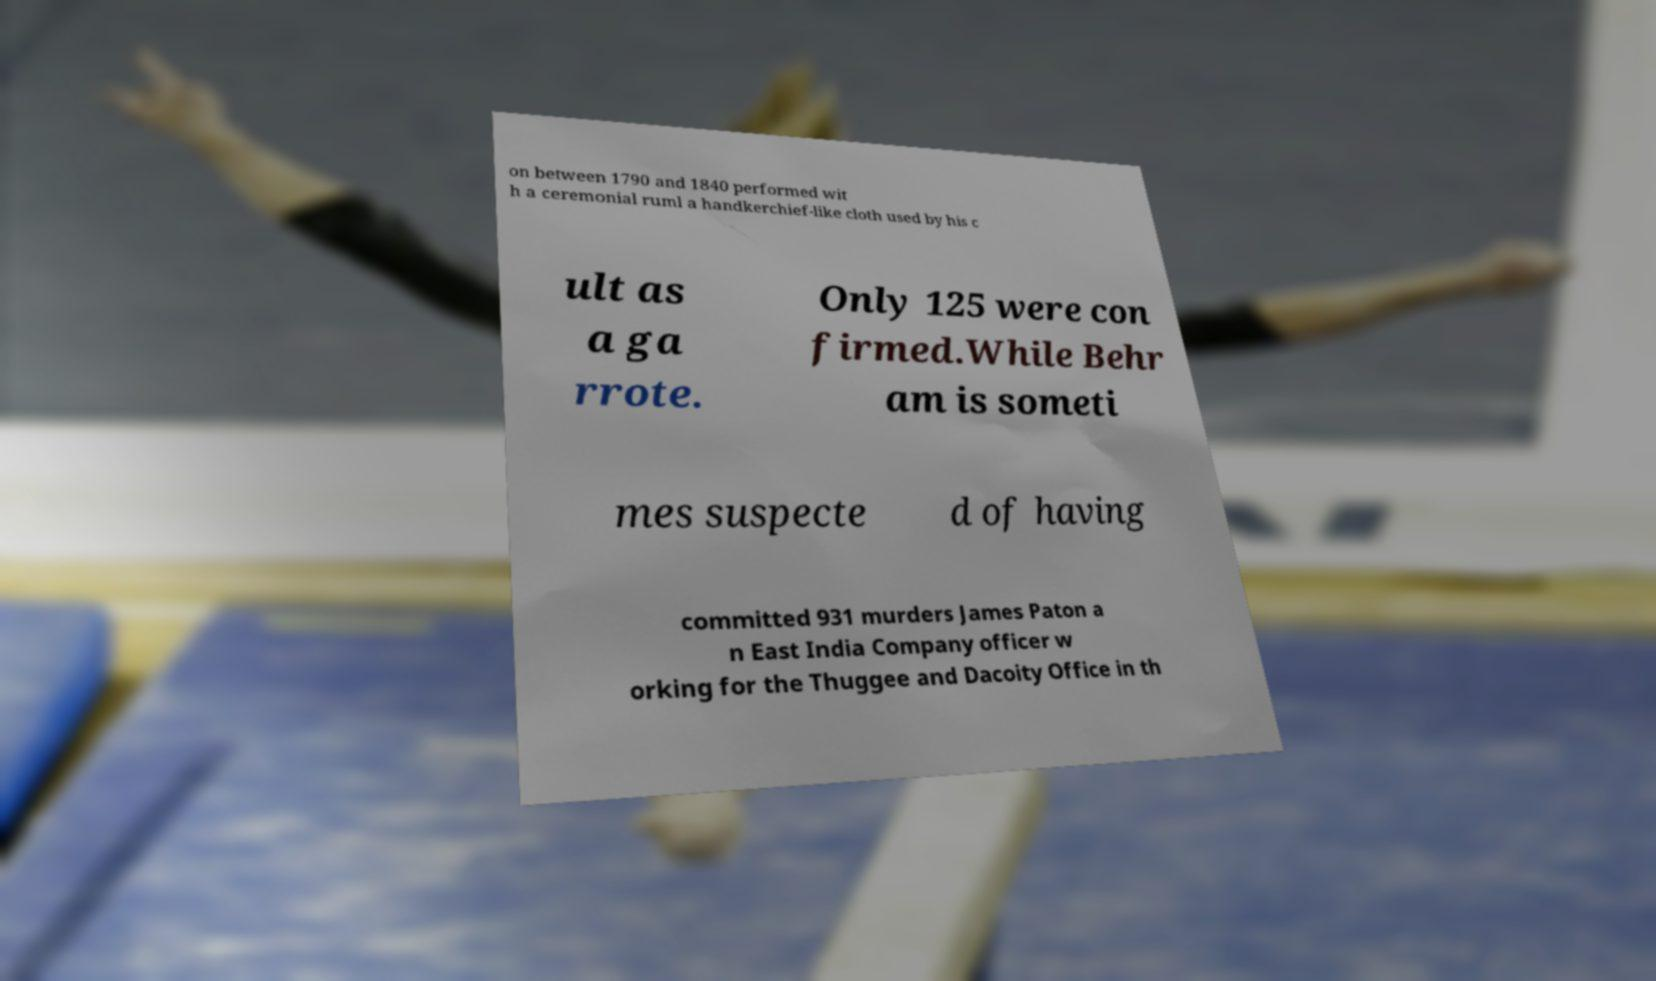Could you extract and type out the text from this image? on between 1790 and 1840 performed wit h a ceremonial ruml a handkerchief-like cloth used by his c ult as a ga rrote. Only 125 were con firmed.While Behr am is someti mes suspecte d of having committed 931 murders James Paton a n East India Company officer w orking for the Thuggee and Dacoity Office in th 